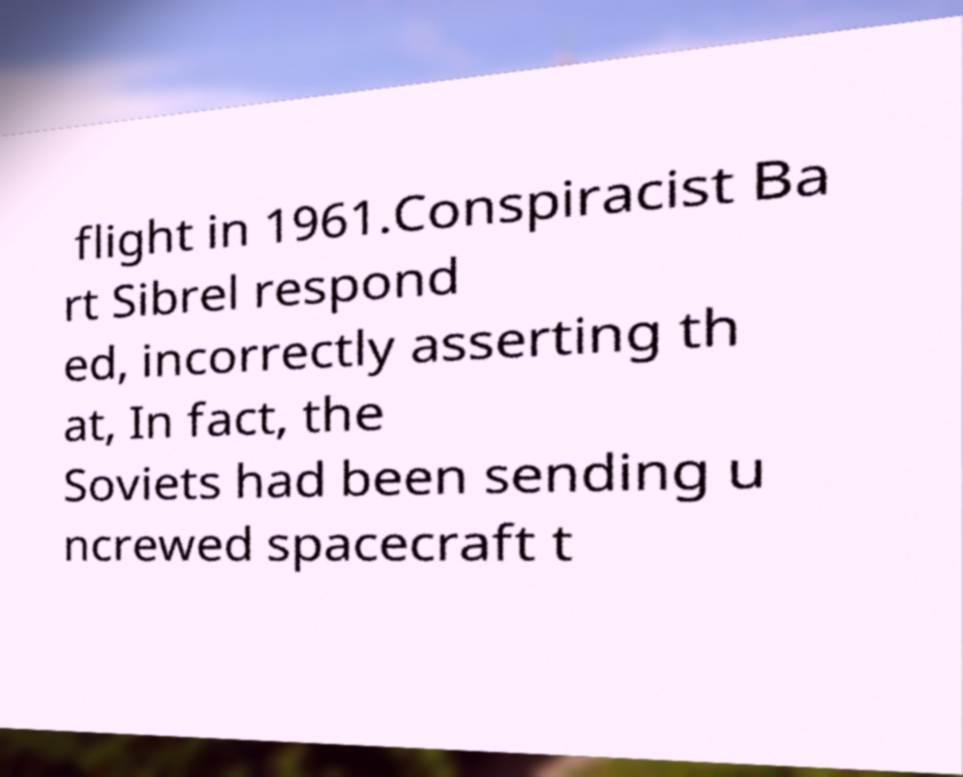Could you assist in decoding the text presented in this image and type it out clearly? flight in 1961.Conspiracist Ba rt Sibrel respond ed, incorrectly asserting th at, In fact, the Soviets had been sending u ncrewed spacecraft t 